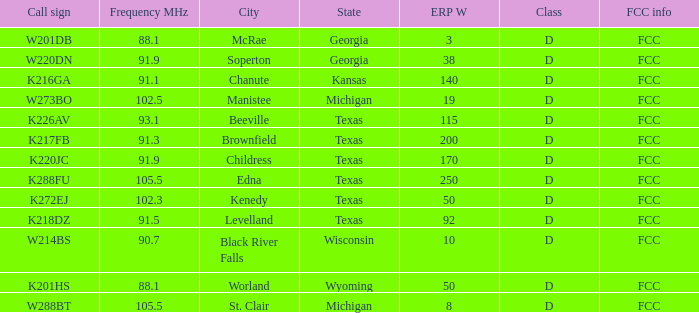What is Call Sign, when City of License is Brownfield, Texas? K217FB. 